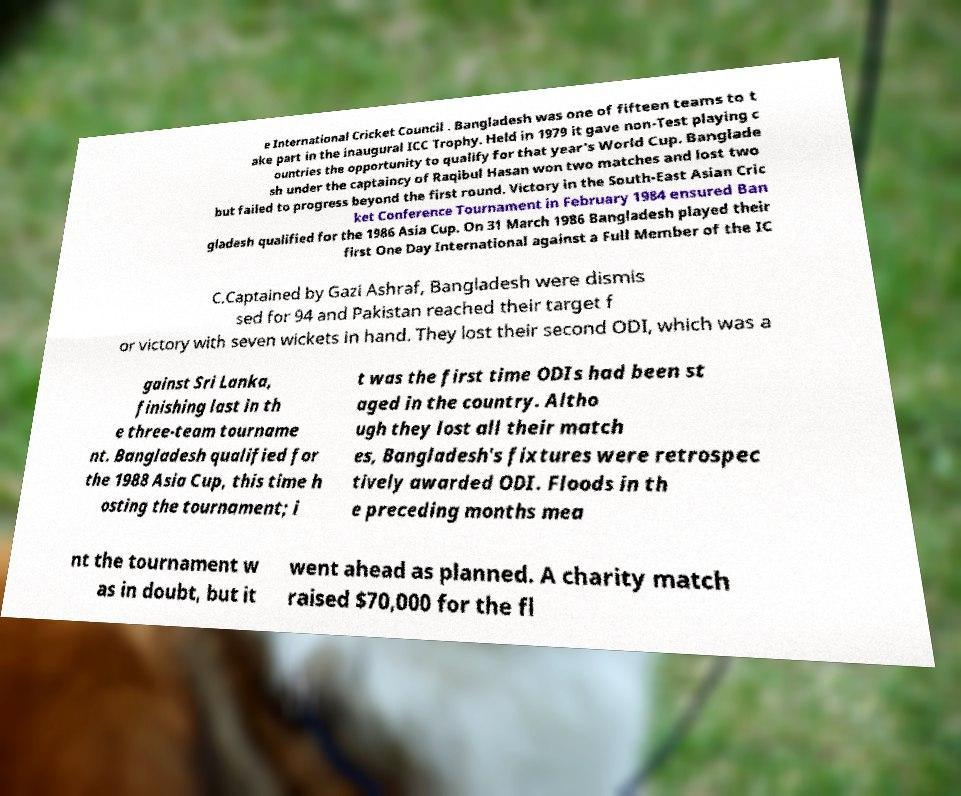I need the written content from this picture converted into text. Can you do that? e International Cricket Council . Bangladesh was one of fifteen teams to t ake part in the inaugural ICC Trophy. Held in 1979 it gave non-Test playing c ountries the opportunity to qualify for that year's World Cup. Banglade sh under the captaincy of Raqibul Hasan won two matches and lost two but failed to progress beyond the first round. Victory in the South-East Asian Cric ket Conference Tournament in February 1984 ensured Ban gladesh qualified for the 1986 Asia Cup. On 31 March 1986 Bangladesh played their first One Day International against a Full Member of the IC C.Captained by Gazi Ashraf, Bangladesh were dismis sed for 94 and Pakistan reached their target f or victory with seven wickets in hand. They lost their second ODI, which was a gainst Sri Lanka, finishing last in th e three-team tourname nt. Bangladesh qualified for the 1988 Asia Cup, this time h osting the tournament; i t was the first time ODIs had been st aged in the country. Altho ugh they lost all their match es, Bangladesh's fixtures were retrospec tively awarded ODI. Floods in th e preceding months mea nt the tournament w as in doubt, but it went ahead as planned. A charity match raised $70,000 for the fl 